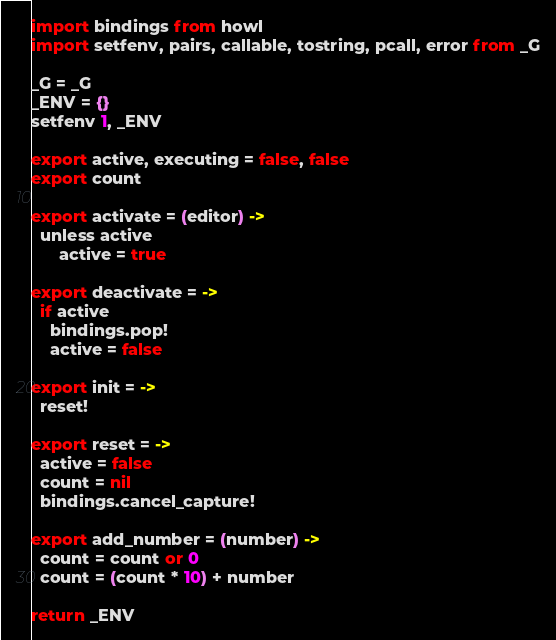Convert code to text. <code><loc_0><loc_0><loc_500><loc_500><_MoonScript_>import bindings from howl
import setfenv, pairs, callable, tostring, pcall, error from _G

_G = _G
_ENV = {}
setfenv 1, _ENV

export active, executing = false, false
export count

export activate = (editor) ->
  unless active
      active = true

export deactivate = ->
  if active
    bindings.pop!
    active = false

export init = ->
  reset!

export reset = ->
  active = false
  count = nil
  bindings.cancel_capture!

export add_number = (number) ->
  count = count or 0
  count = (count * 10) + number
  
return _ENV
</code> 